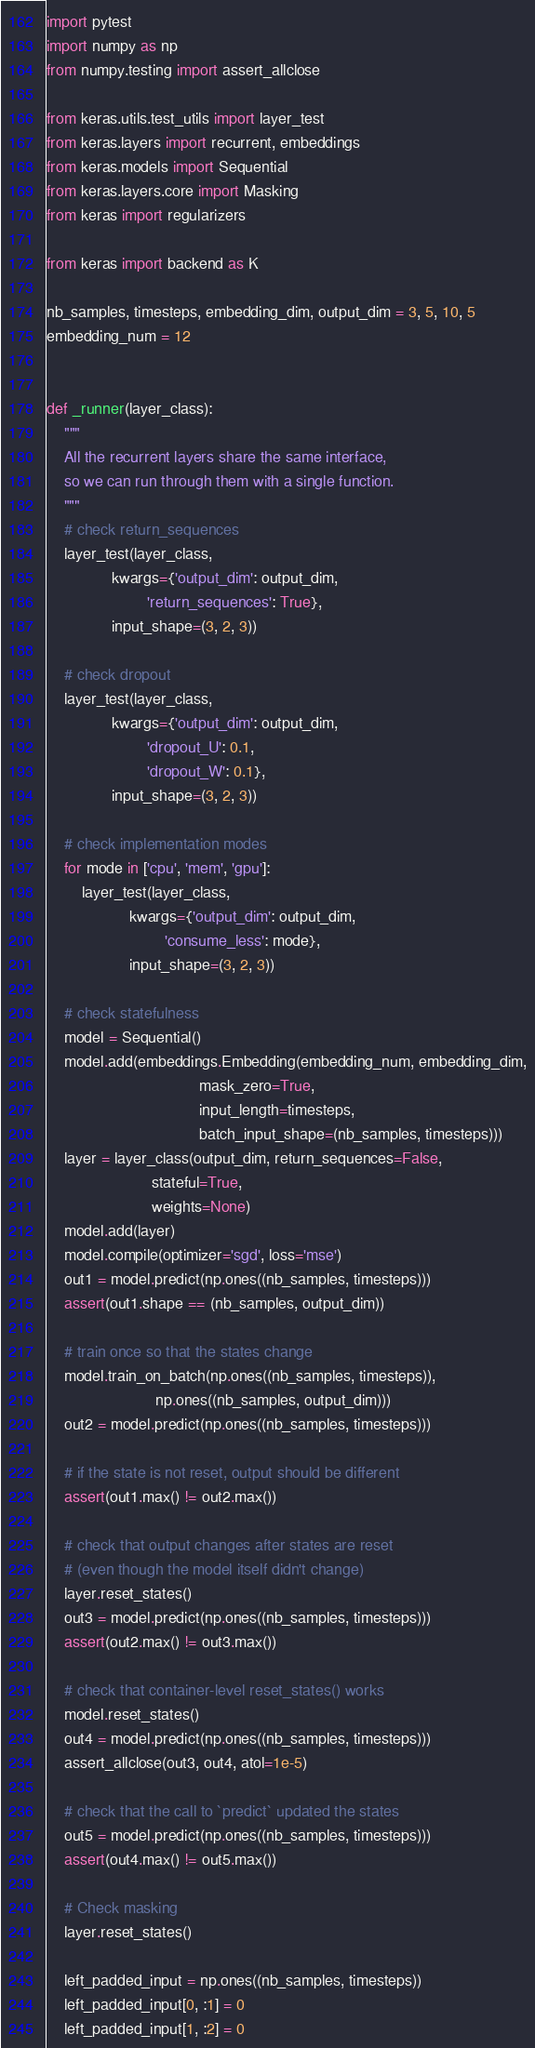<code> <loc_0><loc_0><loc_500><loc_500><_Python_>import pytest
import numpy as np
from numpy.testing import assert_allclose

from keras.utils.test_utils import layer_test
from keras.layers import recurrent, embeddings
from keras.models import Sequential
from keras.layers.core import Masking
from keras import regularizers

from keras import backend as K

nb_samples, timesteps, embedding_dim, output_dim = 3, 5, 10, 5
embedding_num = 12


def _runner(layer_class):
    """
    All the recurrent layers share the same interface,
    so we can run through them with a single function.
    """
    # check return_sequences
    layer_test(layer_class,
               kwargs={'output_dim': output_dim,
                       'return_sequences': True},
               input_shape=(3, 2, 3))

    # check dropout
    layer_test(layer_class,
               kwargs={'output_dim': output_dim,
                       'dropout_U': 0.1,
                       'dropout_W': 0.1},
               input_shape=(3, 2, 3))

    # check implementation modes
    for mode in ['cpu', 'mem', 'gpu']:
        layer_test(layer_class,
                   kwargs={'output_dim': output_dim,
                           'consume_less': mode},
                   input_shape=(3, 2, 3))

    # check statefulness
    model = Sequential()
    model.add(embeddings.Embedding(embedding_num, embedding_dim,
                                   mask_zero=True,
                                   input_length=timesteps,
                                   batch_input_shape=(nb_samples, timesteps)))
    layer = layer_class(output_dim, return_sequences=False,
                        stateful=True,
                        weights=None)
    model.add(layer)
    model.compile(optimizer='sgd', loss='mse')
    out1 = model.predict(np.ones((nb_samples, timesteps)))
    assert(out1.shape == (nb_samples, output_dim))

    # train once so that the states change
    model.train_on_batch(np.ones((nb_samples, timesteps)),
                         np.ones((nb_samples, output_dim)))
    out2 = model.predict(np.ones((nb_samples, timesteps)))

    # if the state is not reset, output should be different
    assert(out1.max() != out2.max())

    # check that output changes after states are reset
    # (even though the model itself didn't change)
    layer.reset_states()
    out3 = model.predict(np.ones((nb_samples, timesteps)))
    assert(out2.max() != out3.max())

    # check that container-level reset_states() works
    model.reset_states()
    out4 = model.predict(np.ones((nb_samples, timesteps)))
    assert_allclose(out3, out4, atol=1e-5)

    # check that the call to `predict` updated the states
    out5 = model.predict(np.ones((nb_samples, timesteps)))
    assert(out4.max() != out5.max())

    # Check masking
    layer.reset_states()

    left_padded_input = np.ones((nb_samples, timesteps))
    left_padded_input[0, :1] = 0
    left_padded_input[1, :2] = 0</code> 